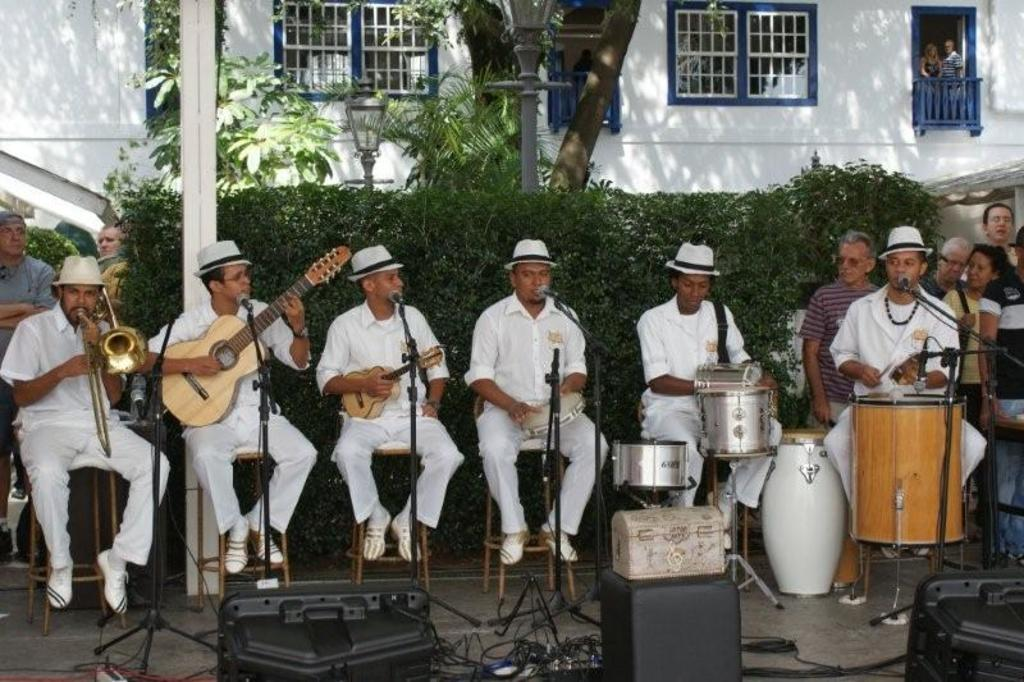What are the men in the image doing? The men are sitting and playing musical instruments in the image. Can you describe the background of the image? There is a tree, a wall, and a window in the background of the image. Are there any other people visible in the image? Yes, there are other persons standing in the background. What type of stew is being served at the airport in the image? There is no airport or stew present in the image; it features men playing musical instruments with other persons standing in the background. What sound can be heard coming from the instruments in the image? The image is a still picture, so no sound can be heard. 